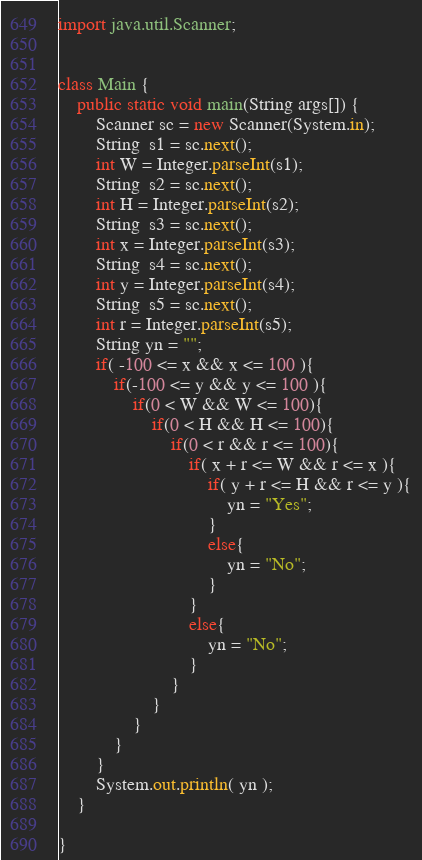Convert code to text. <code><loc_0><loc_0><loc_500><loc_500><_Java_>import java.util.Scanner;


class Main {
	public static void main(String args[]) {
	    Scanner sc = new Scanner(System.in);
	    String  s1 = sc.next();
	    int W = Integer.parseInt(s1);
	    String  s2 = sc.next();
	    int H = Integer.parseInt(s2);
	    String  s3 = sc.next();
	    int x = Integer.parseInt(s3);
	    String  s4 = sc.next();
	    int y = Integer.parseInt(s4);
	    String  s5 = sc.next();
	    int r = Integer.parseInt(s5);
	    String yn = "";
	    if( -100 <= x && x <= 100 ){
	    	if(-100 <= y && y <= 100 ){
	    		if(0 < W && W <= 100){
	    			if(0 < H && H <= 100){
	    				if(0 < r && r <= 100){
	                        if( x + r <= W && r <= x ){
	                            if( y + r <= H && r <= y ){
	                            	yn = "Yes";
	                            }
	                            else{
		        	                yn = "No";
	                            }
	                        }
	                        else{
	        	                yn = "No";
	                        }
	    			    }
	    			}
	    		}
	    	}
	    }
	    System.out.println( yn );
	}

}</code> 